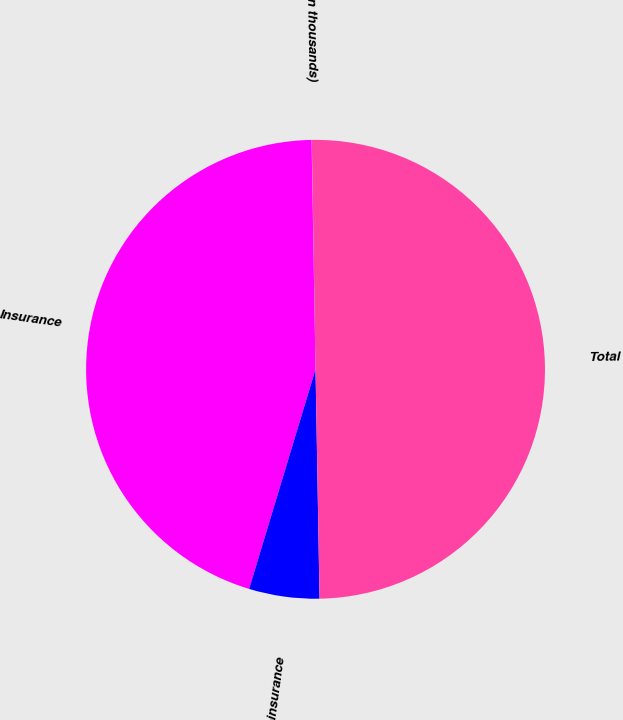<chart> <loc_0><loc_0><loc_500><loc_500><pie_chart><fcel>(In thousands)<fcel>Insurance<fcel>Reinsurance<fcel>Total<nl><fcel>0.02%<fcel>45.05%<fcel>4.95%<fcel>49.98%<nl></chart> 